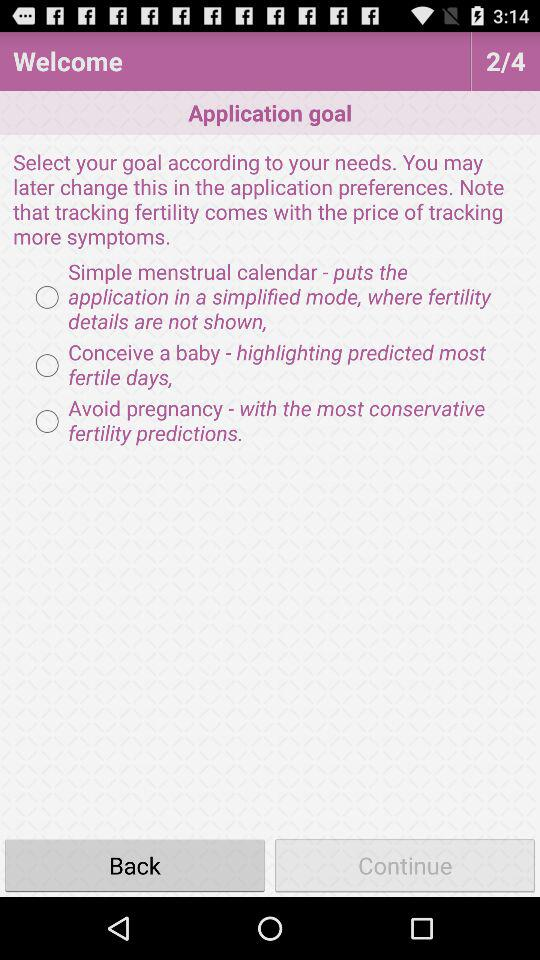Which page are we currently on? You are currently on the "Application goal" page. 